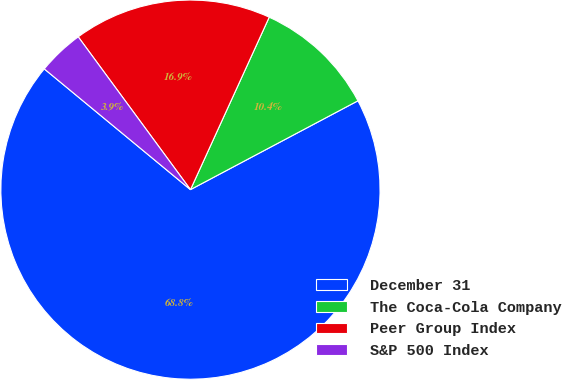<chart> <loc_0><loc_0><loc_500><loc_500><pie_chart><fcel>December 31<fcel>The Coca-Cola Company<fcel>Peer Group Index<fcel>S&P 500 Index<nl><fcel>68.75%<fcel>10.42%<fcel>16.9%<fcel>3.93%<nl></chart> 